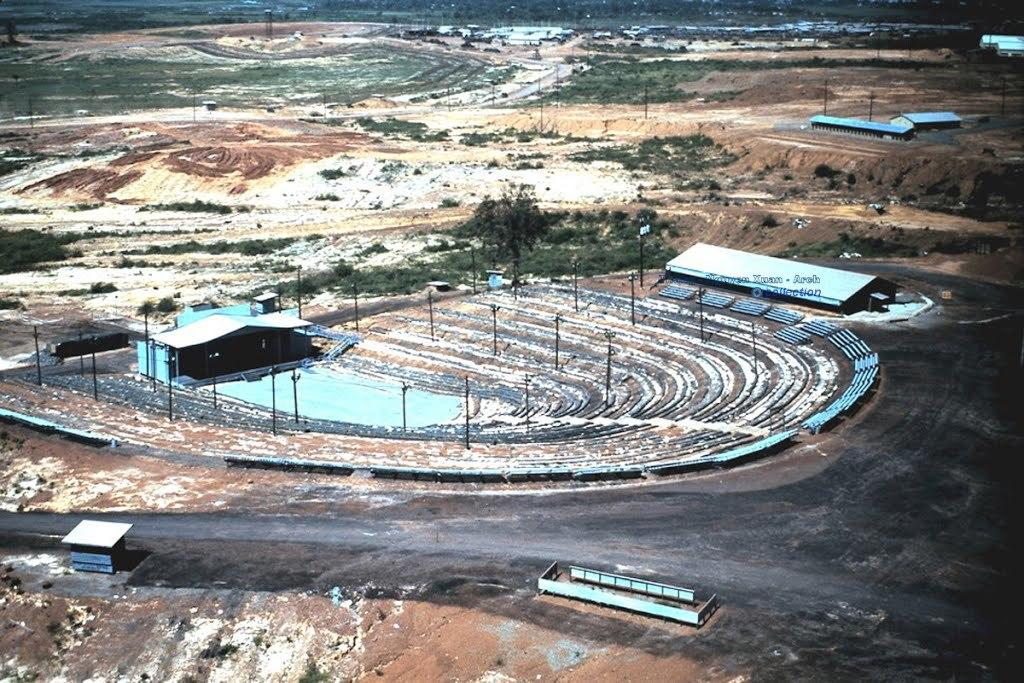What type of structures can be seen in the image? There are houses in the image. What else can be seen on the ground in the image? There are poles and objects present on the ground in the image. What is visible in the background of the image? There is grass visible in the background of the image. Are there any poles in the background of the image? Yes, there are poles on the ground in the background of the image. What type of soup is being served in the image? There is no soup present in the image. Can you tell me how the self is interacting with the houses in the image? There is no self or person present in the image; it only shows houses, poles, and objects on the ground. 